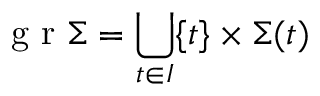<formula> <loc_0><loc_0><loc_500><loc_500>g r \Sigma = \bigcup _ { t \in I } \{ t \} \times \Sigma ( t )</formula> 